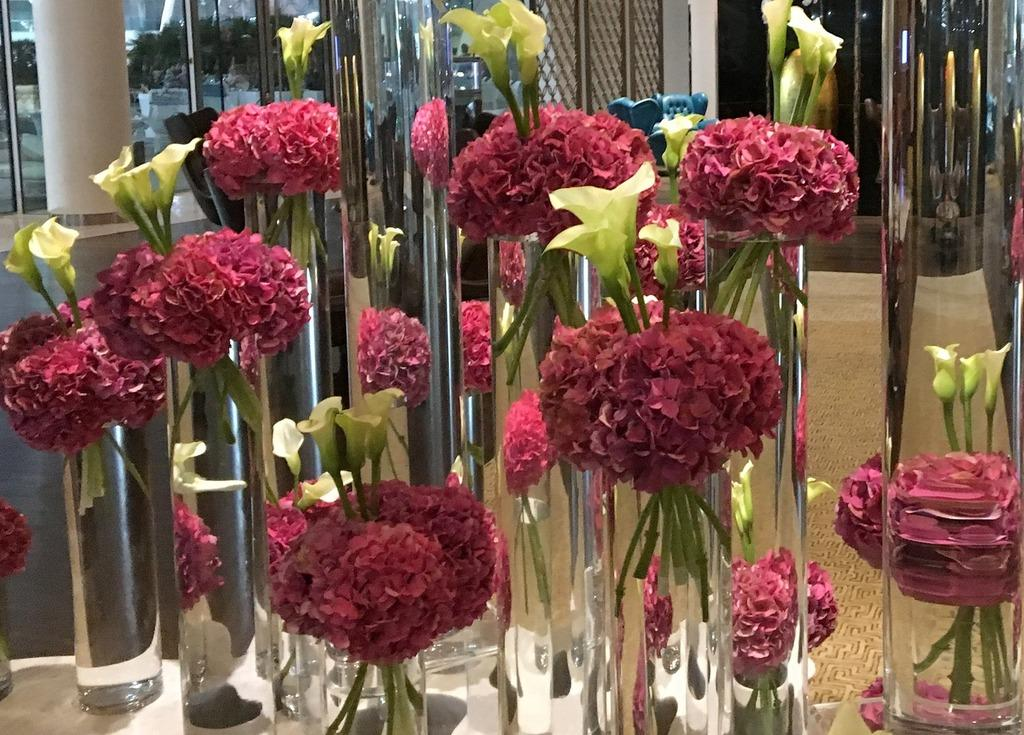What is the main subject of the image? There are so many flowers in the image. What is the flowers placed in? There is a flower vase in the image. What is inside the vase? There is water in the image. What is the color of the surface the flowers, vase, and water are placed on? The flowers, vase, and water are placed on a white surface. What can be seen in the background of the image? There are glasses and a pillar in the background of the image. What type of floor is visible in the background? There is a floor in the background of the image. What type of wave can be seen crashing on the shore in the image? There is no wave or shore present in the image; it features flowers in a vase on a white surface. How many patches of grass are visible in the image? There are no patches of grass visible in the image; it features flowers in a vase on a white surface. 